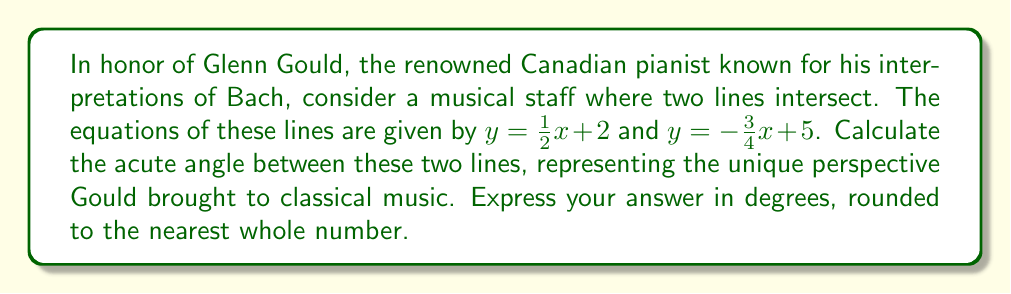What is the answer to this math problem? To find the angle between two intersecting lines, we can use the formula:

$$\tan \theta = \left|\frac{m_1 - m_2}{1 + m_1m_2}\right|$$

where $m_1$ and $m_2$ are the slopes of the two lines, and $\theta$ is the acute angle between them.

1) First, identify the slopes:
   For $y = \frac{1}{2}x + 2$, $m_1 = \frac{1}{2}$
   For $y = -\frac{3}{4}x + 5$, $m_2 = -\frac{3}{4}$

2) Substitute these values into the formula:

   $$\tan \theta = \left|\frac{\frac{1}{2} - (-\frac{3}{4})}{1 + \frac{1}{2}(-\frac{3}{4})}\right|$$

3) Simplify the numerator and denominator:

   $$\tan \theta = \left|\frac{\frac{1}{2} + \frac{3}{4}}{1 - \frac{3}{8}}\right| = \left|\frac{\frac{5}{4}}{\frac{5}{8}}\right|$$

4) Divide:

   $$\tan \theta = \frac{5}{4} \cdot \frac{8}{5} = 2$$

5) To find $\theta$, we need to calculate the inverse tangent (arctangent):

   $$\theta = \arctan(2)$$

6) Convert to degrees:

   $$\theta \approx 63.4349^\circ$$

7) Rounding to the nearest whole number:

   $$\theta \approx 63^\circ$$
Answer: $63^\circ$ 